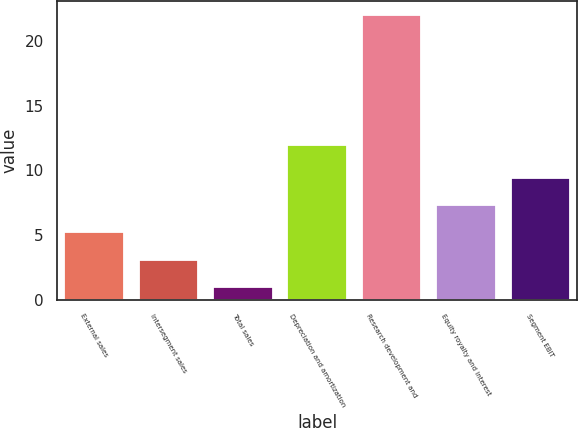Convert chart to OTSL. <chart><loc_0><loc_0><loc_500><loc_500><bar_chart><fcel>External sales<fcel>Intersegment sales<fcel>Total sales<fcel>Depreciation and amortization<fcel>Research development and<fcel>Equity royalty and interest<fcel>Segment EBIT<nl><fcel>5.2<fcel>3.1<fcel>1<fcel>12<fcel>22<fcel>7.3<fcel>9.4<nl></chart> 